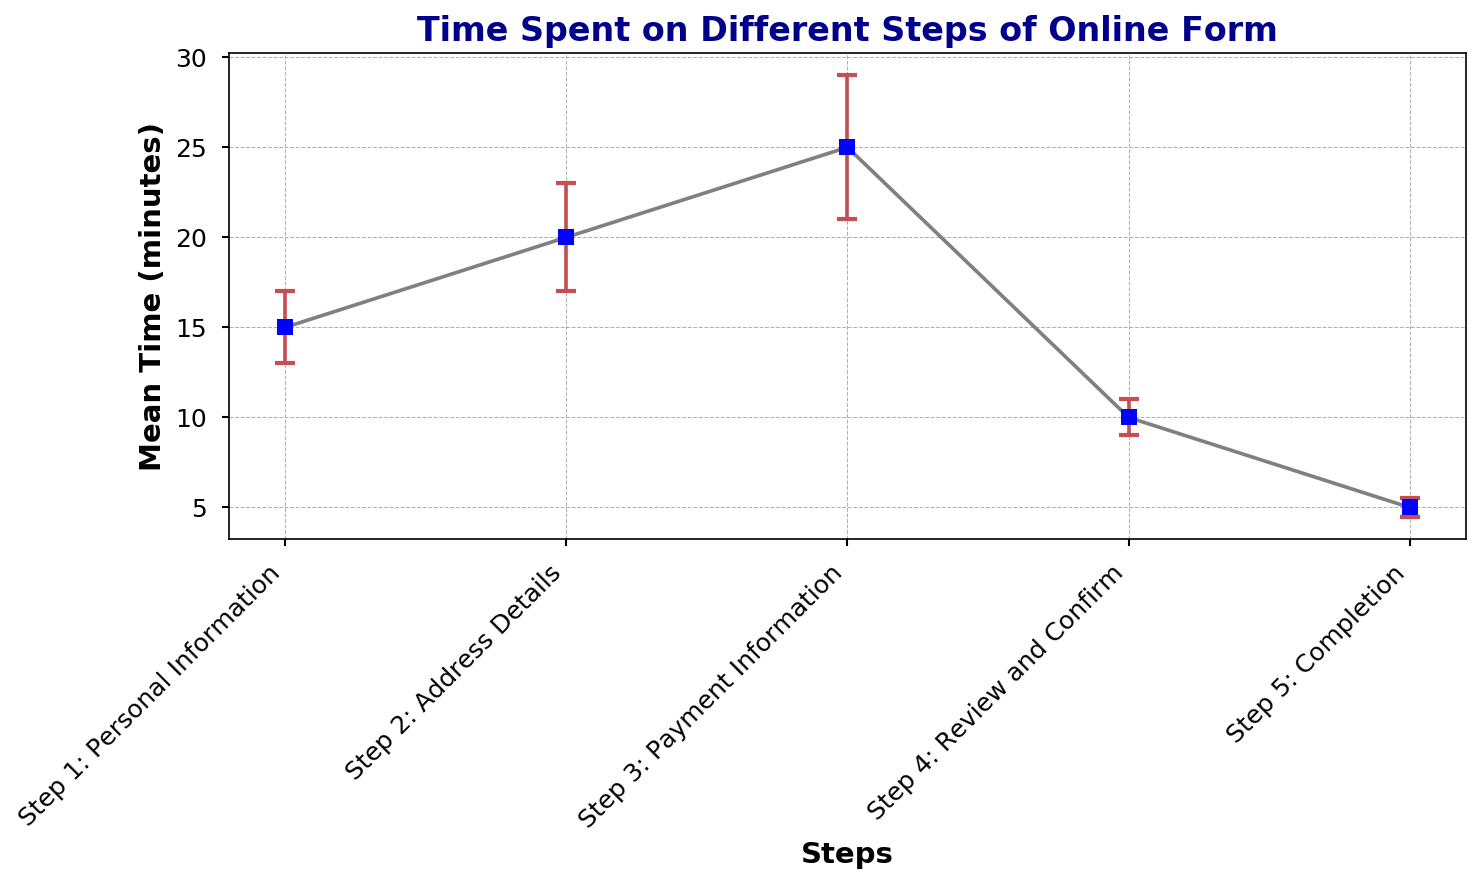What is the mean time for Step 3: Payment Information? The mean time for Step 3: Payment Information is directly indicated on the error bar plot as 25 minutes.
Answer: 25 minutes What is the difference in mean time between Step 2: Address Details and Step 4: Review and Confirm? The mean time for Step 2: Address Details is 20 minutes and for Step 4: Review and Confirm is 10 minutes. The difference is calculated as 20 - 10 = 10 minutes.
Answer: 10 minutes Which step has the highest variability in the time spent? The highest variability is represented by the largest error bar. Step 3: Payment Information has the largest error bar with a standard deviation of 4 minutes.
Answer: Step 3: Payment Information What is the sum of the mean times for all steps? Sum the mean times for all steps: 15 (Step 1) + 20 (Step 2) + 25 (Step 3) + 10 (Step 4) + 5 (Step 5) = 75 minutes.
Answer: 75 minutes How does the mean time for Step 2: Address Details compare to the mean time for Step 5: Completion? The mean time for Step 2: Address Details is 20 minutes, which is larger than the mean time for Step 5: Completion, which is 5 minutes.
Answer: Step 2: Address Details > Step 5: Completion What is the average standard deviation across all steps? The standard deviations for each step are 2, 3, 4, 1, and 0.5. The average standard deviation is calculated as (2 + 3 + 4 + 1 + 0.5) / 5 = 2.1 minutes.
Answer: 2.1 minutes What do the colors of the points and error bars represent in the plot? In the plot, the points are marked in blue, and the error bars are marked in red, providing a visual distinction between the mean times and their variability.
Answer: The points are blue, and the error bars are red 